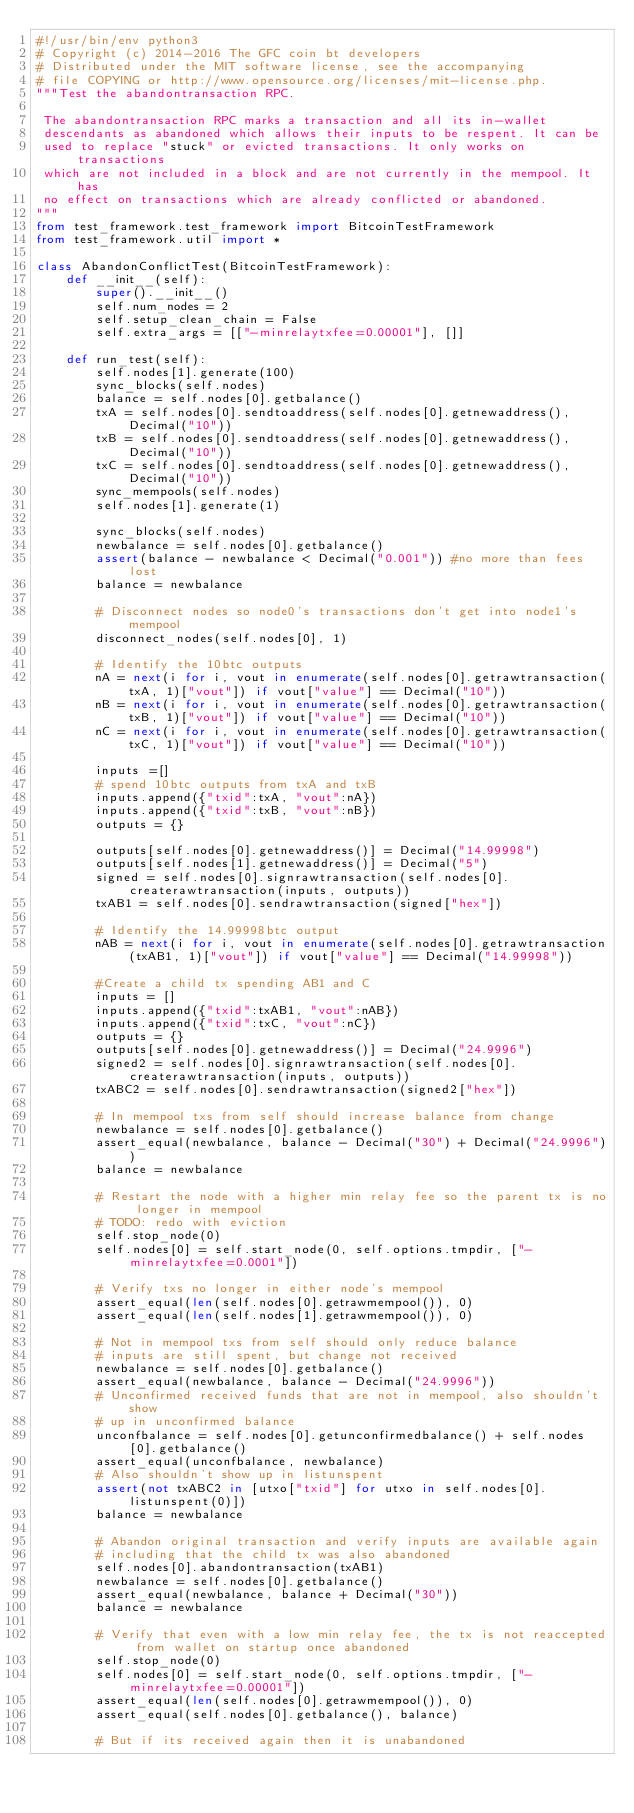<code> <loc_0><loc_0><loc_500><loc_500><_Python_>#!/usr/bin/env python3
# Copyright (c) 2014-2016 The GFC coin bt developers
# Distributed under the MIT software license, see the accompanying
# file COPYING or http://www.opensource.org/licenses/mit-license.php.
"""Test the abandontransaction RPC.

 The abandontransaction RPC marks a transaction and all its in-wallet
 descendants as abandoned which allows their inputs to be respent. It can be
 used to replace "stuck" or evicted transactions. It only works on transactions
 which are not included in a block and are not currently in the mempool. It has
 no effect on transactions which are already conflicted or abandoned.
"""
from test_framework.test_framework import BitcoinTestFramework
from test_framework.util import *

class AbandonConflictTest(BitcoinTestFramework):
    def __init__(self):
        super().__init__()
        self.num_nodes = 2
        self.setup_clean_chain = False
        self.extra_args = [["-minrelaytxfee=0.00001"], []]

    def run_test(self):
        self.nodes[1].generate(100)
        sync_blocks(self.nodes)
        balance = self.nodes[0].getbalance()
        txA = self.nodes[0].sendtoaddress(self.nodes[0].getnewaddress(), Decimal("10"))
        txB = self.nodes[0].sendtoaddress(self.nodes[0].getnewaddress(), Decimal("10"))
        txC = self.nodes[0].sendtoaddress(self.nodes[0].getnewaddress(), Decimal("10"))
        sync_mempools(self.nodes)
        self.nodes[1].generate(1)

        sync_blocks(self.nodes)
        newbalance = self.nodes[0].getbalance()
        assert(balance - newbalance < Decimal("0.001")) #no more than fees lost
        balance = newbalance

        # Disconnect nodes so node0's transactions don't get into node1's mempool
        disconnect_nodes(self.nodes[0], 1)

        # Identify the 10btc outputs
        nA = next(i for i, vout in enumerate(self.nodes[0].getrawtransaction(txA, 1)["vout"]) if vout["value"] == Decimal("10"))
        nB = next(i for i, vout in enumerate(self.nodes[0].getrawtransaction(txB, 1)["vout"]) if vout["value"] == Decimal("10"))
        nC = next(i for i, vout in enumerate(self.nodes[0].getrawtransaction(txC, 1)["vout"]) if vout["value"] == Decimal("10"))

        inputs =[]
        # spend 10btc outputs from txA and txB
        inputs.append({"txid":txA, "vout":nA})
        inputs.append({"txid":txB, "vout":nB})
        outputs = {}

        outputs[self.nodes[0].getnewaddress()] = Decimal("14.99998")
        outputs[self.nodes[1].getnewaddress()] = Decimal("5")
        signed = self.nodes[0].signrawtransaction(self.nodes[0].createrawtransaction(inputs, outputs))
        txAB1 = self.nodes[0].sendrawtransaction(signed["hex"])

        # Identify the 14.99998btc output
        nAB = next(i for i, vout in enumerate(self.nodes[0].getrawtransaction(txAB1, 1)["vout"]) if vout["value"] == Decimal("14.99998"))

        #Create a child tx spending AB1 and C
        inputs = []
        inputs.append({"txid":txAB1, "vout":nAB})
        inputs.append({"txid":txC, "vout":nC})
        outputs = {}
        outputs[self.nodes[0].getnewaddress()] = Decimal("24.9996")
        signed2 = self.nodes[0].signrawtransaction(self.nodes[0].createrawtransaction(inputs, outputs))
        txABC2 = self.nodes[0].sendrawtransaction(signed2["hex"])

        # In mempool txs from self should increase balance from change
        newbalance = self.nodes[0].getbalance()
        assert_equal(newbalance, balance - Decimal("30") + Decimal("24.9996"))
        balance = newbalance

        # Restart the node with a higher min relay fee so the parent tx is no longer in mempool
        # TODO: redo with eviction
        self.stop_node(0)
        self.nodes[0] = self.start_node(0, self.options.tmpdir, ["-minrelaytxfee=0.0001"])

        # Verify txs no longer in either node's mempool
        assert_equal(len(self.nodes[0].getrawmempool()), 0)
        assert_equal(len(self.nodes[1].getrawmempool()), 0)

        # Not in mempool txs from self should only reduce balance
        # inputs are still spent, but change not received
        newbalance = self.nodes[0].getbalance()
        assert_equal(newbalance, balance - Decimal("24.9996"))
        # Unconfirmed received funds that are not in mempool, also shouldn't show
        # up in unconfirmed balance
        unconfbalance = self.nodes[0].getunconfirmedbalance() + self.nodes[0].getbalance()
        assert_equal(unconfbalance, newbalance)
        # Also shouldn't show up in listunspent
        assert(not txABC2 in [utxo["txid"] for utxo in self.nodes[0].listunspent(0)])
        balance = newbalance

        # Abandon original transaction and verify inputs are available again
        # including that the child tx was also abandoned
        self.nodes[0].abandontransaction(txAB1)
        newbalance = self.nodes[0].getbalance()
        assert_equal(newbalance, balance + Decimal("30"))
        balance = newbalance

        # Verify that even with a low min relay fee, the tx is not reaccepted from wallet on startup once abandoned
        self.stop_node(0)
        self.nodes[0] = self.start_node(0, self.options.tmpdir, ["-minrelaytxfee=0.00001"])
        assert_equal(len(self.nodes[0].getrawmempool()), 0)
        assert_equal(self.nodes[0].getbalance(), balance)

        # But if its received again then it is unabandoned</code> 